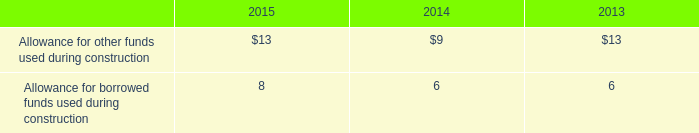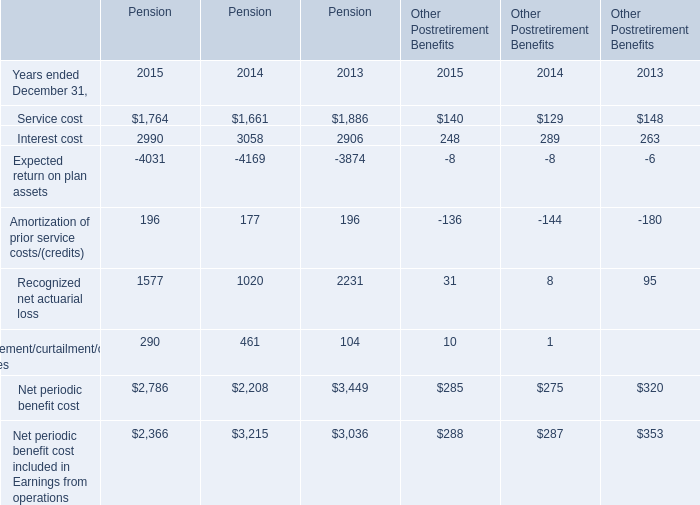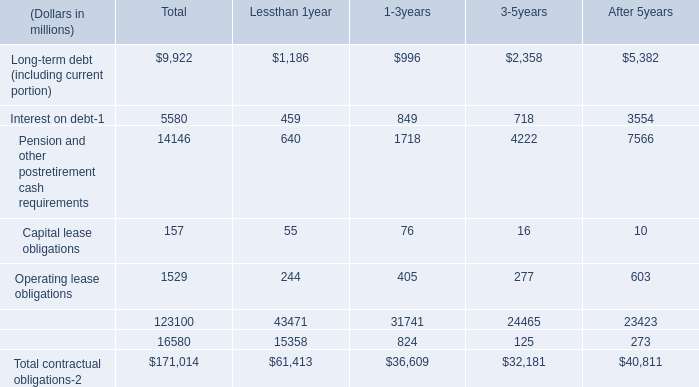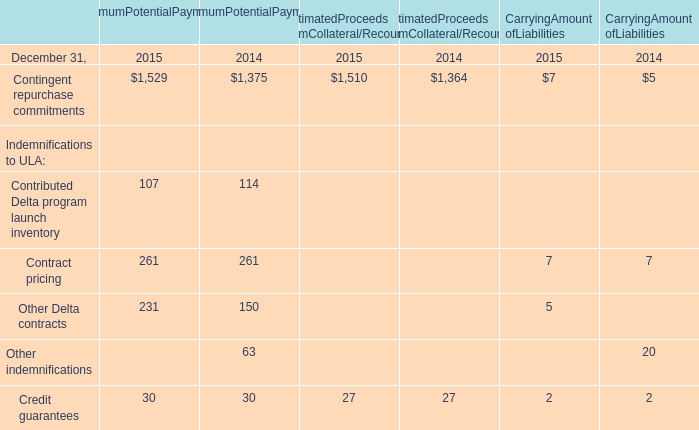What is the ratio of Service cost to the Contingent repurchase commitments in 2015 ? 
Computations: (1764 / 1529)
Answer: 1.1537. 